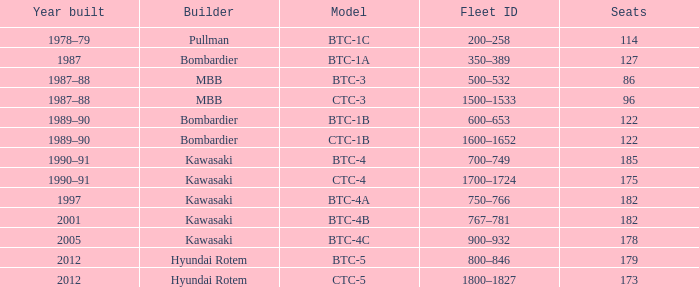In the btc-5 model, what is the total number of seats? 179.0. Would you be able to parse every entry in this table? {'header': ['Year built', 'Builder', 'Model', 'Fleet ID', 'Seats'], 'rows': [['1978–79', 'Pullman', 'BTC-1C', '200–258', '114'], ['1987', 'Bombardier', 'BTC-1A', '350–389', '127'], ['1987–88', 'MBB', 'BTC-3', '500–532', '86'], ['1987–88', 'MBB', 'CTC-3', '1500–1533', '96'], ['1989–90', 'Bombardier', 'BTC-1B', '600–653', '122'], ['1989–90', 'Bombardier', 'CTC-1B', '1600–1652', '122'], ['1990–91', 'Kawasaki', 'BTC-4', '700–749', '185'], ['1990–91', 'Kawasaki', 'CTC-4', '1700–1724', '175'], ['1997', 'Kawasaki', 'BTC-4A', '750–766', '182'], ['2001', 'Kawasaki', 'BTC-4B', '767–781', '182'], ['2005', 'Kawasaki', 'BTC-4C', '900–932', '178'], ['2012', 'Hyundai Rotem', 'BTC-5', '800–846', '179'], ['2012', 'Hyundai Rotem', 'CTC-5', '1800–1827', '173']]} 